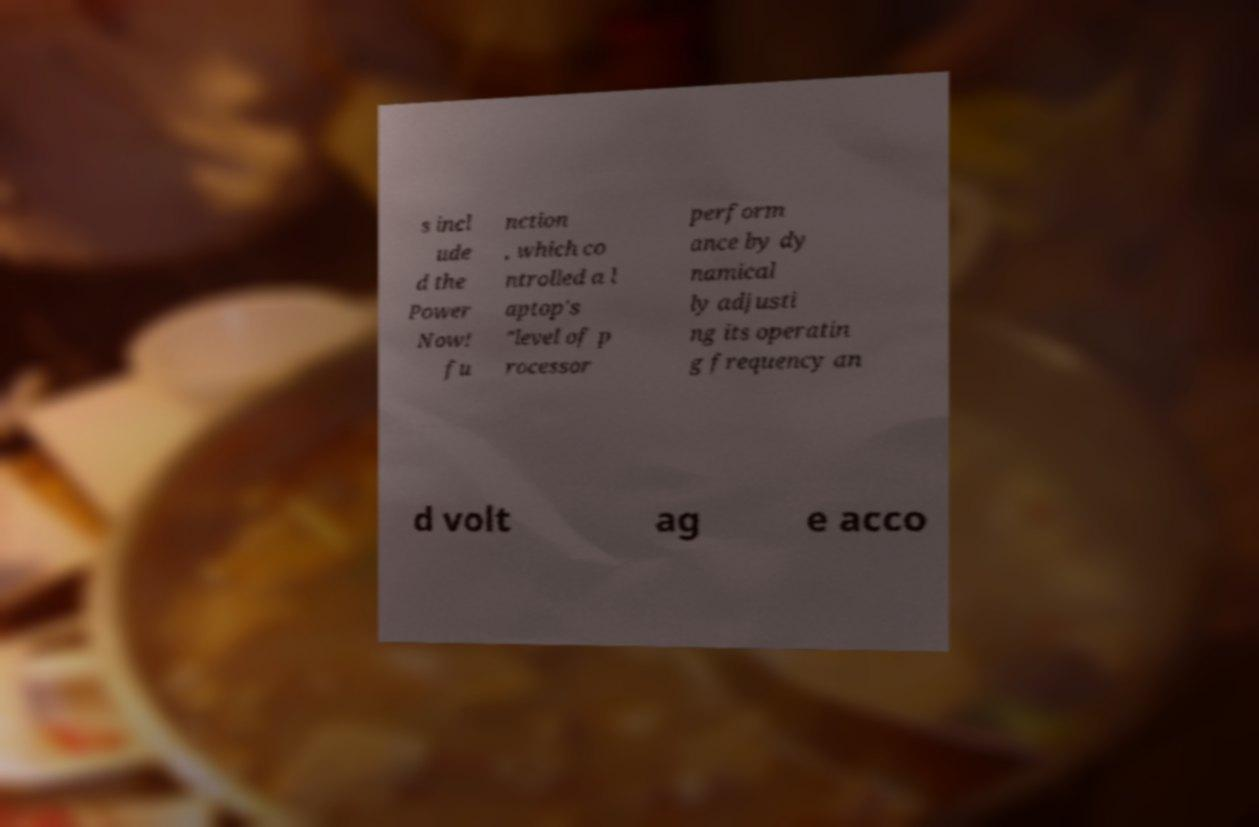There's text embedded in this image that I need extracted. Can you transcribe it verbatim? s incl ude d the Power Now! fu nction , which co ntrolled a l aptop's "level of p rocessor perform ance by dy namical ly adjusti ng its operatin g frequency an d volt ag e acco 